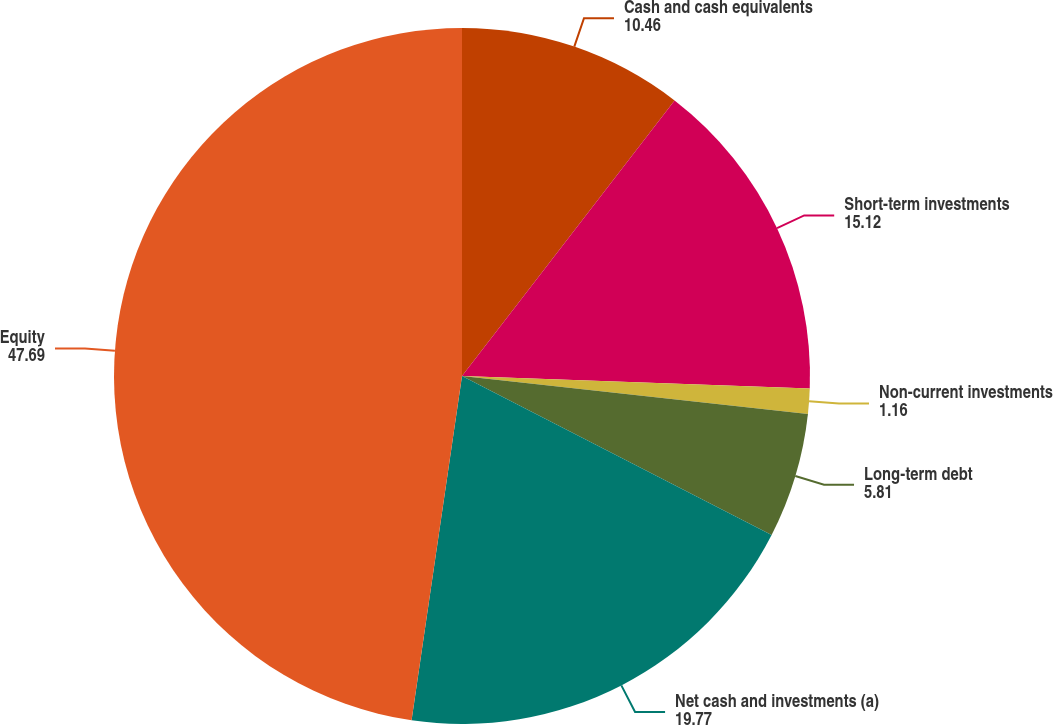Convert chart to OTSL. <chart><loc_0><loc_0><loc_500><loc_500><pie_chart><fcel>Cash and cash equivalents<fcel>Short-term investments<fcel>Non-current investments<fcel>Long-term debt<fcel>Net cash and investments (a)<fcel>Equity<nl><fcel>10.46%<fcel>15.12%<fcel>1.16%<fcel>5.81%<fcel>19.77%<fcel>47.69%<nl></chart> 